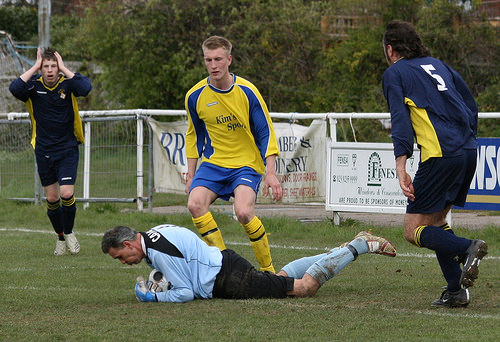<image>
Is the guy behind the other guy? Yes. From this viewpoint, the guy is positioned behind the other guy, with the other guy partially or fully occluding the guy. Is there a ball behind the shoe? No. The ball is not behind the shoe. From this viewpoint, the ball appears to be positioned elsewhere in the scene. 